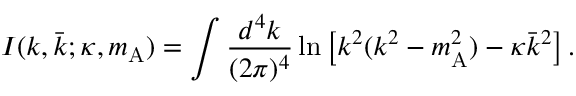Convert formula to latex. <formula><loc_0><loc_0><loc_500><loc_500>I ( k , \bar { k } ; \kappa , m _ { A } ) = \int \frac { d ^ { 4 } k } { ( 2 \pi ) ^ { 4 } } \ln \left [ k ^ { 2 } ( k ^ { 2 } - m _ { A } ^ { 2 } ) - \kappa \bar { k } ^ { 2 } \right ] .</formula> 